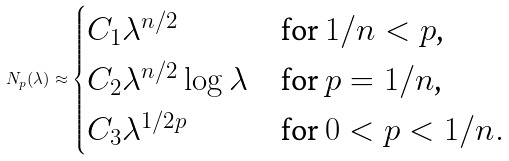<formula> <loc_0><loc_0><loc_500><loc_500>N _ { p } ( \lambda ) \approx \begin{cases} C _ { 1 } \lambda ^ { n / 2 } & \text {for $1/n< p$,} \\ C _ { 2 } \lambda ^ { n / 2 } \log \lambda & \text {for $p=1/n$,} \\ C _ { 3 } \lambda ^ { 1 / 2 p } & \text {for $0<p<1/n$} . \end{cases}</formula> 